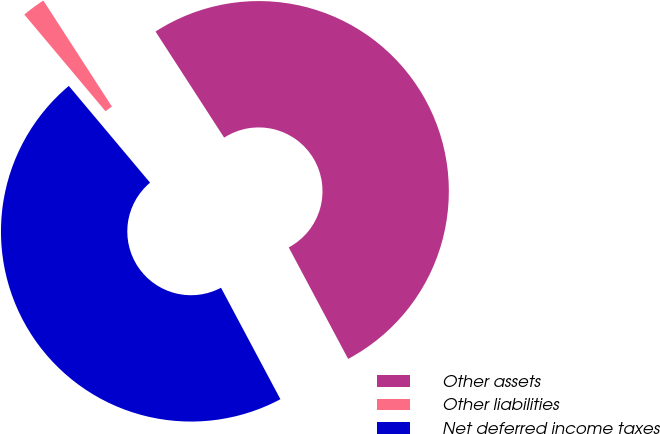<chart> <loc_0><loc_0><loc_500><loc_500><pie_chart><fcel>Other assets<fcel>Other liabilities<fcel>Net deferred income taxes<nl><fcel>51.34%<fcel>1.98%<fcel>46.67%<nl></chart> 